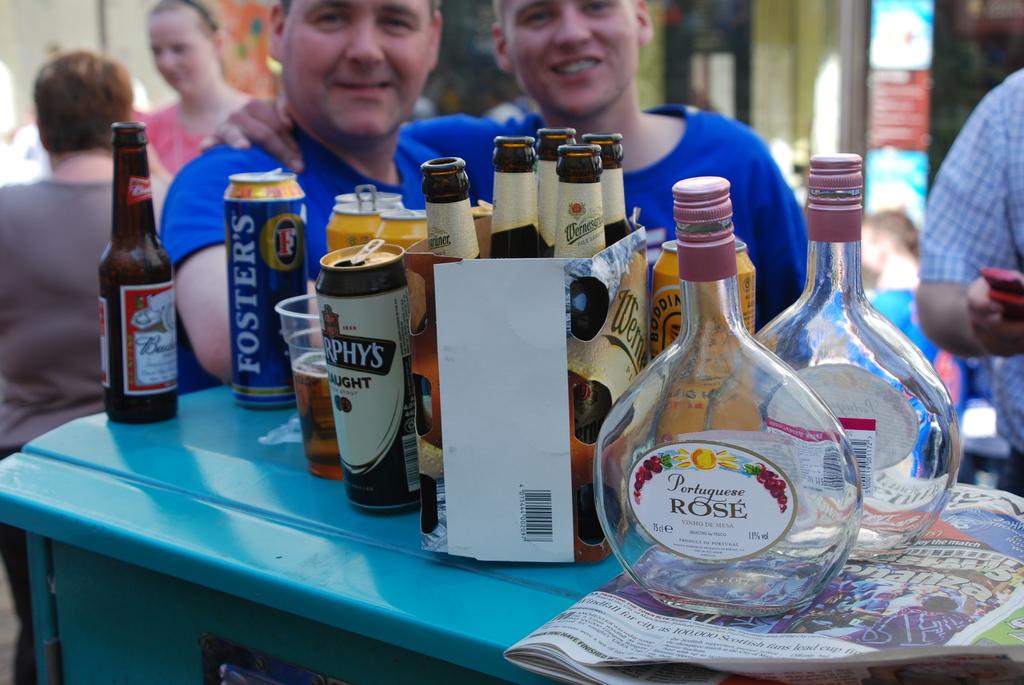What wine did they drink?
Your answer should be compact. Rose. What's the name of the beer blue can in the back?
Offer a very short reply. Foster's. 